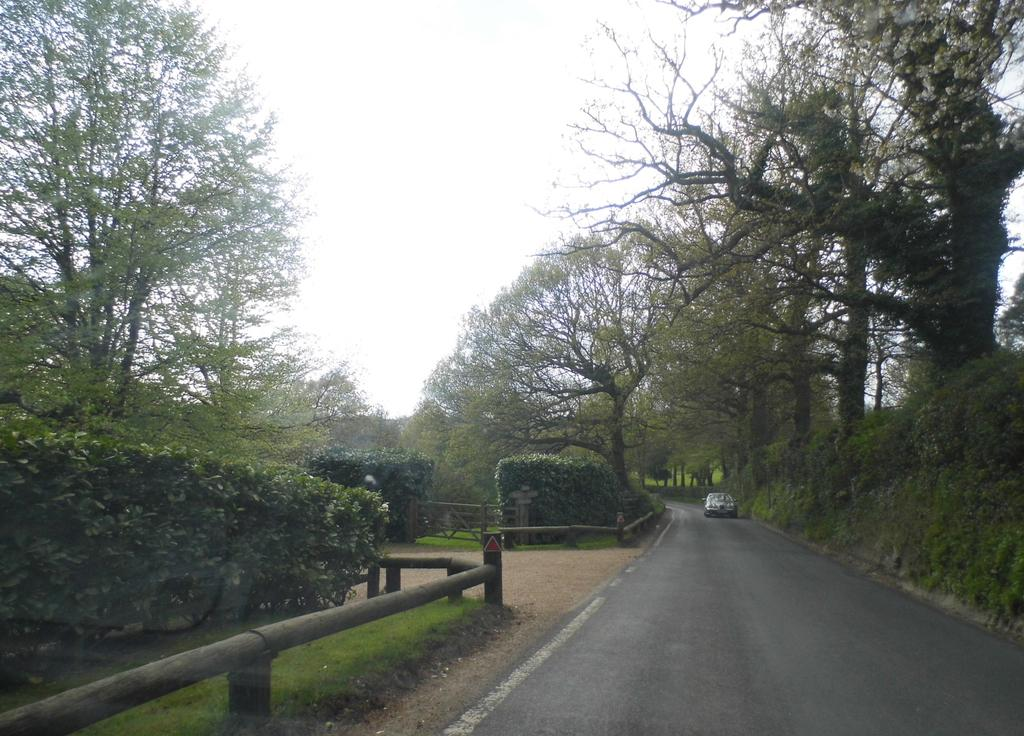What type of vegetation can be seen in the image? There are trees in the image. What is on the road in the image? There is a car on the road in the image. What type of barrier is present in the image? There is a wooden fence in the image. What is the condition of the sky in the image? The sky is cloudy in the image. Where is the key located in the image? There is no key present in the image. What type of trail can be seen in the image? There is no trail visible in the image; it features trees, a car, a wooden fence, and a cloudy sky. 